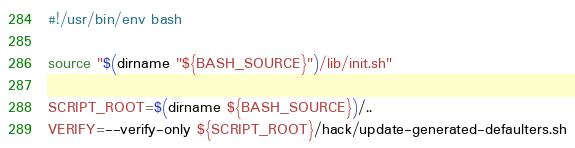<code> <loc_0><loc_0><loc_500><loc_500><_Bash_>#!/usr/bin/env bash

source "$(dirname "${BASH_SOURCE}")/lib/init.sh"

SCRIPT_ROOT=$(dirname ${BASH_SOURCE})/..
VERIFY=--verify-only ${SCRIPT_ROOT}/hack/update-generated-defaulters.sh
</code> 